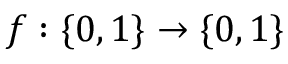<formula> <loc_0><loc_0><loc_500><loc_500>f \colon \{ 0 , 1 \} \rightarrow \{ 0 , 1 \}</formula> 